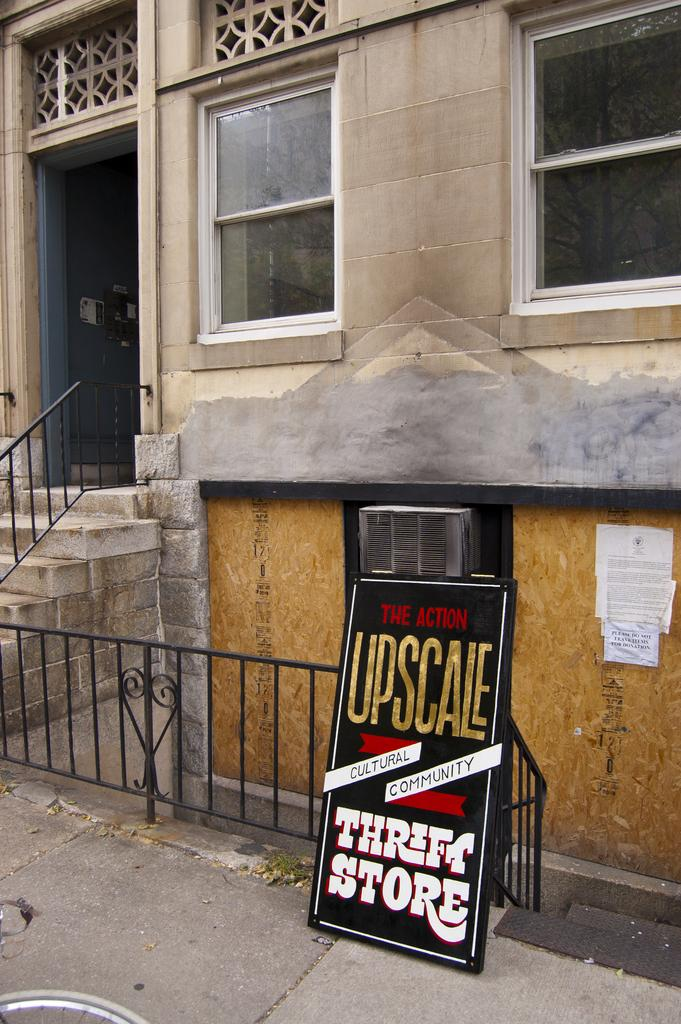What is the main object in the middle of the image? There is a black-colored board in the middle of the image. What does the board represent? The board represents a house. What architectural feature can be seen on the left side of the image? There is a staircase on the left side of the image. What type of force is being applied to the zinc in the image? There is no zinc present in the image, and therefore no force is being applied to it. 